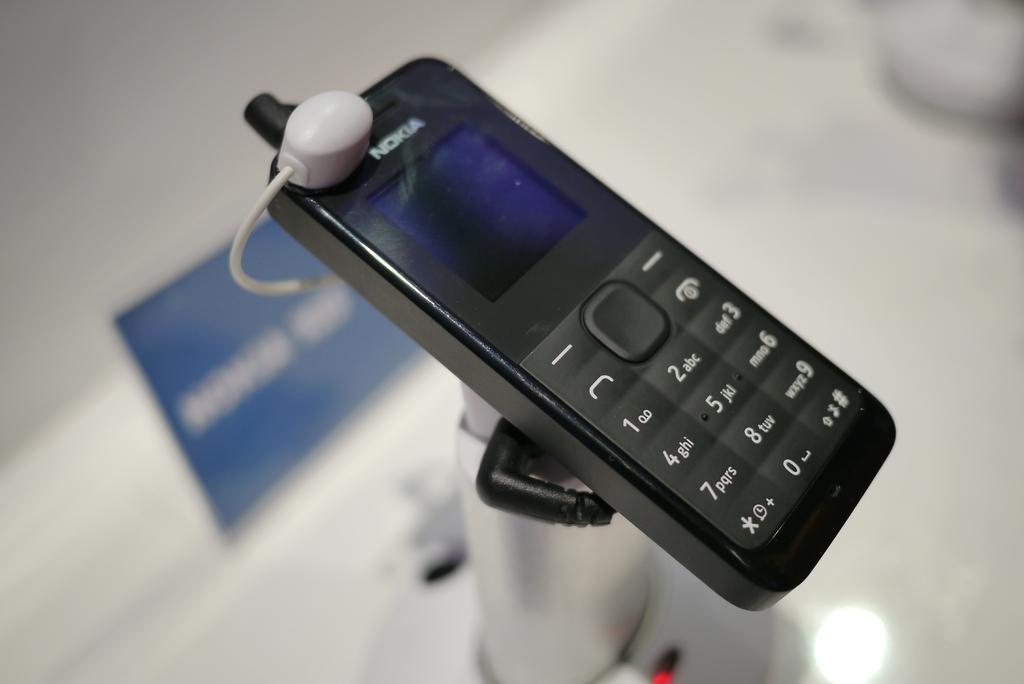Describe this image in one or two sentences. In this image we can see a mobile phone with a connector placed on the stand. We can also see a name board on the surface. 